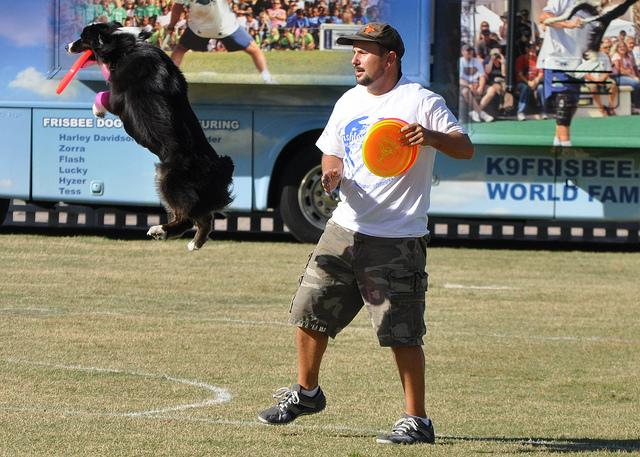Why did the dog jump in the air? Please explain your reasoning. catch. The dog got the frisbee. 